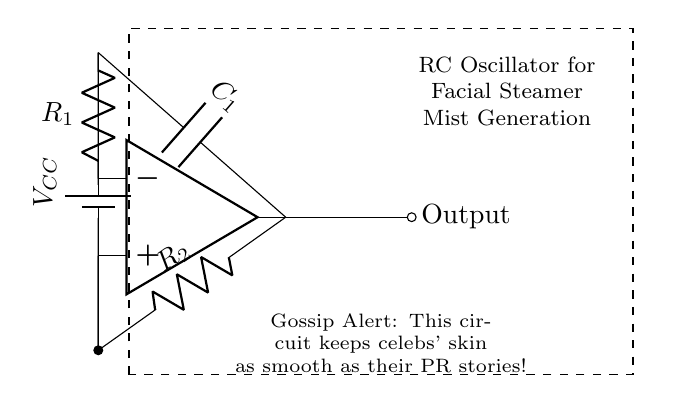What type of oscillator is shown? The circuit is an RC oscillator, which is indicated by the use of resistors and capacitors in a feedback arrangement to generate oscillations.
Answer: RC oscillator What are the main components in this circuit? The main components identified in the circuit are two resistors and one capacitor, which together form the oscillator circuit.
Answer: Two resistors and one capacitor What is the function of the op-amp in this circuit? The op-amp is utilized as a voltage amplifier, providing the gain necessary for the oscillation to occur by amplifying the voltage across the capacitor and allowing feedback into the circuit.
Answer: Voltage amplifier What is the role of the capacitor in oscillation generation? The capacitor stores and releases energy, causing the circuit to produce periodic oscillations as it charges and discharges. This periodic behavior is key to generating consistent mist for the facial steamer.
Answer: Energy storage and release What is the significance of the output in this circuit? The output from the op-amp is where the oscillation occurs, which controls the mist generation for the facial steamer, ensuring a consistent and stable mist output.
Answer: Controls mist generation What is the voltage supply in this RC oscillator? The voltage supply, represented by VCC in the circuit, powers the components and is essential for the operation of the oscillator. In typical designs, this is often a few volts, commonly around five volts in portable applications.
Answer: VCC 